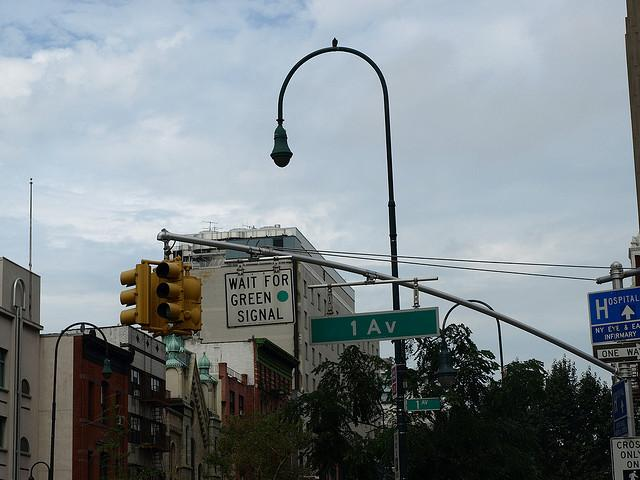What kind of environment is this? Please explain your reasoning. urban. An intersection is shown with tall buildings in the background and signage for a nearby hospital. 